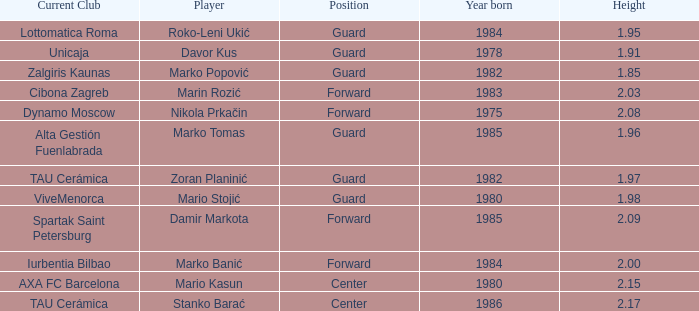What position does Mario Kasun play? Center. Could you parse the entire table? {'header': ['Current Club', 'Player', 'Position', 'Year born', 'Height'], 'rows': [['Lottomatica Roma', 'Roko-Leni Ukić', 'Guard', '1984', '1.95'], ['Unicaja', 'Davor Kus', 'Guard', '1978', '1.91'], ['Zalgiris Kaunas', 'Marko Popović', 'Guard', '1982', '1.85'], ['Cibona Zagreb', 'Marin Rozić', 'Forward', '1983', '2.03'], ['Dynamo Moscow', 'Nikola Prkačin', 'Forward', '1975', '2.08'], ['Alta Gestión Fuenlabrada', 'Marko Tomas', 'Guard', '1985', '1.96'], ['TAU Cerámica', 'Zoran Planinić', 'Guard', '1982', '1.97'], ['ViveMenorca', 'Mario Stojić', 'Guard', '1980', '1.98'], ['Spartak Saint Petersburg', 'Damir Markota', 'Forward', '1985', '2.09'], ['Iurbentia Bilbao', 'Marko Banić', 'Forward', '1984', '2.00'], ['AXA FC Barcelona', 'Mario Kasun', 'Center', '1980', '2.15'], ['TAU Cerámica', 'Stanko Barać', 'Center', '1986', '2.17']]} 